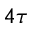<formula> <loc_0><loc_0><loc_500><loc_500>4 \tau</formula> 